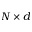<formula> <loc_0><loc_0><loc_500><loc_500>N \times d</formula> 